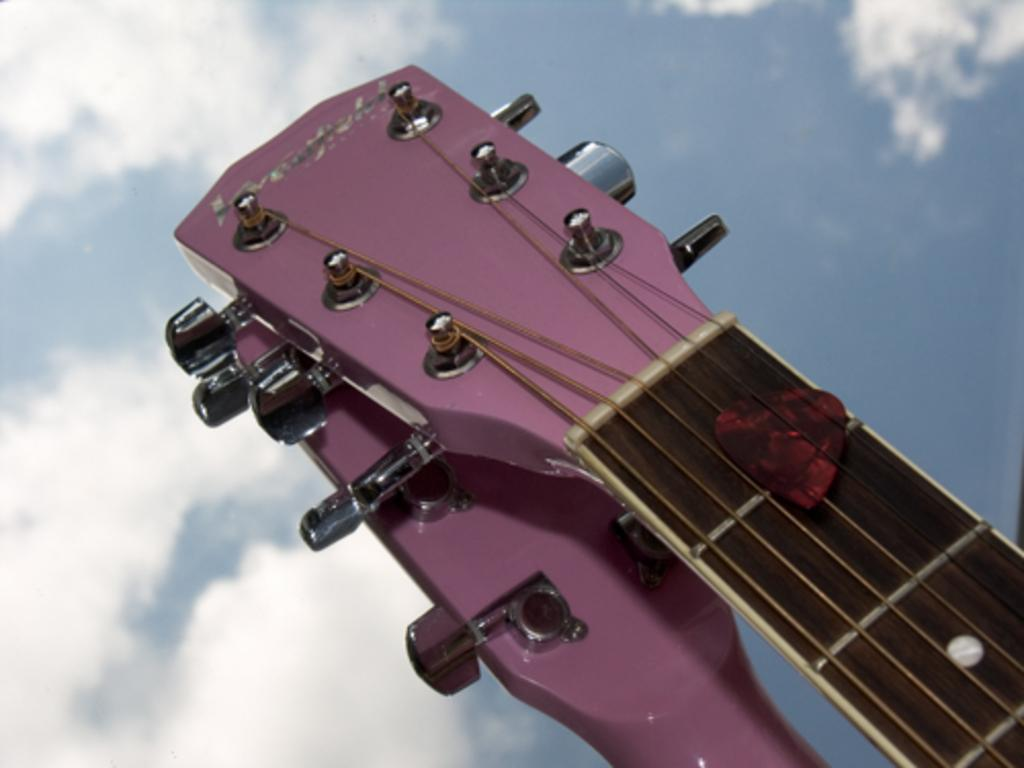What type of accessory is visible in the image? There is a guitar strap in the image. What shape can be seen in the image? There is a heart shape symbol in the image. What type of material is present in the image? There is a wire in the image. What type of fastener is present in the image? There are buttons in the image. What is visible in the background of the image? The sky is visible in the image, and clouds are present in the sky. What type of soup is being served in the image? There is no soup present in the image. What type of flower is blooming on the leg in the image? There is no flower or leg present in the image. 